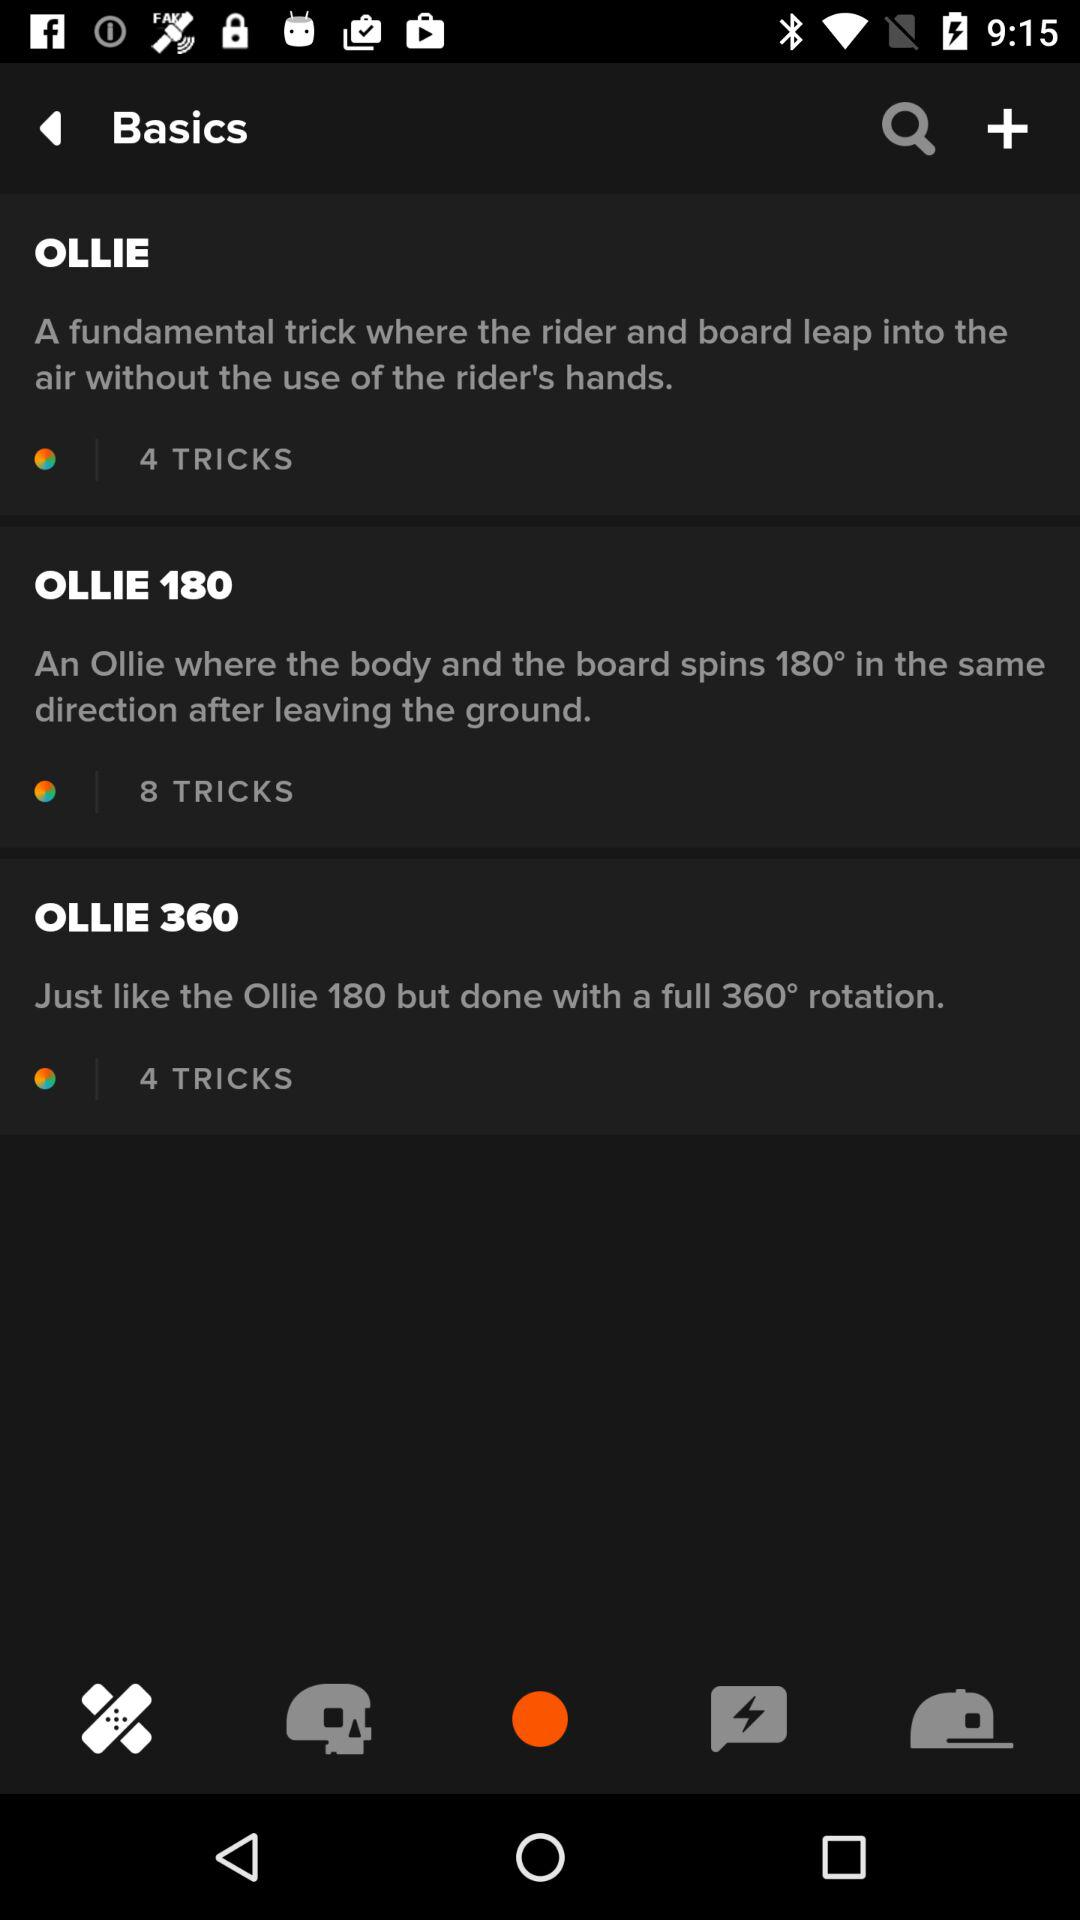How many tricks are there in total for all three Ollie tricks?
Answer the question using a single word or phrase. 16 